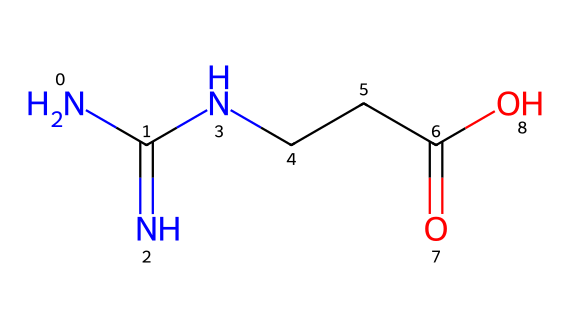What is the main functional group present in creatine? The main functional group in creatine is the carboxylic acid group, identified by the -COOH in the structure.
Answer: carboxylic acid How many nitrogen atoms are present in creatine? In the SMILES representation, there are three nitrogen atoms indicated by 'N' in various parts of the structure.
Answer: three What is the total number of carbon atoms in creatine? The structure shows four carbon atoms, counted from the letters 'C' in the SMILES representation.
Answer: four Is creatine a polar or non-polar molecule? Creatine contains multiple functional groups, including amines and carboxylic acids, which indicate that it can engage in hydrogen bonding, making it polar.
Answer: polar What is the relationship between creatine and ATP? Creatine plays a crucial role in the regeneration of ATP by donating a phosphate group, helping to quickly replenish energy in muscle cells.
Answer: energy regeneration What type of biological function does creatine primarily support? Creatine primarily supports muscle recovery and energy production during high-intensity activities.
Answer: muscle recovery What is the molecular formula of creatine? The molecular formula can be derived from counting the elements in the SMILES, resulting in C4H9N3O2.
Answer: C4H9N3O2 